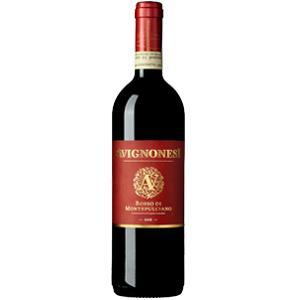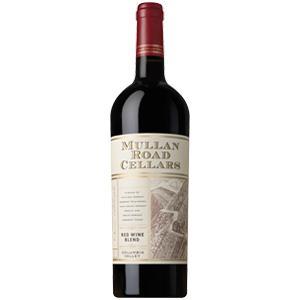The first image is the image on the left, the second image is the image on the right. Given the left and right images, does the statement "Two bottles of wine, one in each image, are sealed closed and have different labels on the body of the bottle." hold true? Answer yes or no. Yes. The first image is the image on the left, the second image is the image on the right. For the images shown, is this caption "Each image shows a single upright wine bottle, and at least one bottle has a red cap wrap." true? Answer yes or no. Yes. 